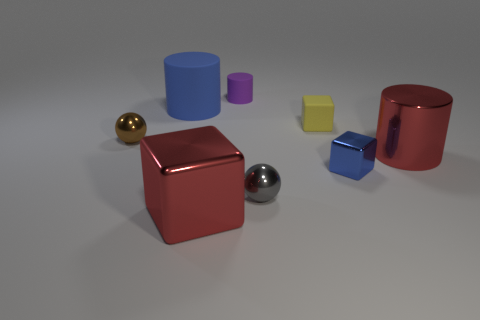Subtract all yellow cubes. How many cubes are left? 2 Add 1 purple matte spheres. How many objects exist? 9 Subtract all red blocks. How many blocks are left? 2 Subtract all cylinders. How many objects are left? 5 Add 5 tiny cyan blocks. How many tiny cyan blocks exist? 5 Subtract 0 gray blocks. How many objects are left? 8 Subtract all cyan cubes. Subtract all blue spheres. How many cubes are left? 3 Subtract all tiny yellow rubber things. Subtract all small objects. How many objects are left? 2 Add 1 metallic things. How many metallic things are left? 6 